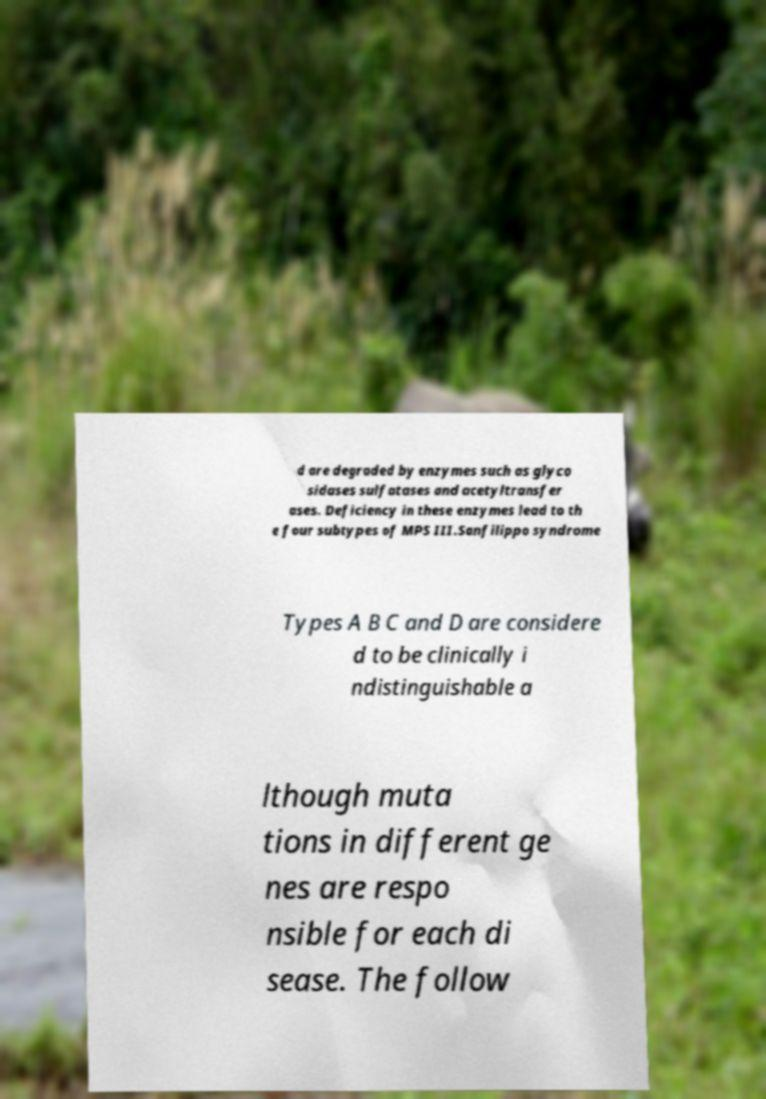Could you extract and type out the text from this image? d are degraded by enzymes such as glyco sidases sulfatases and acetyltransfer ases. Deficiency in these enzymes lead to th e four subtypes of MPS III.Sanfilippo syndrome Types A B C and D are considere d to be clinically i ndistinguishable a lthough muta tions in different ge nes are respo nsible for each di sease. The follow 